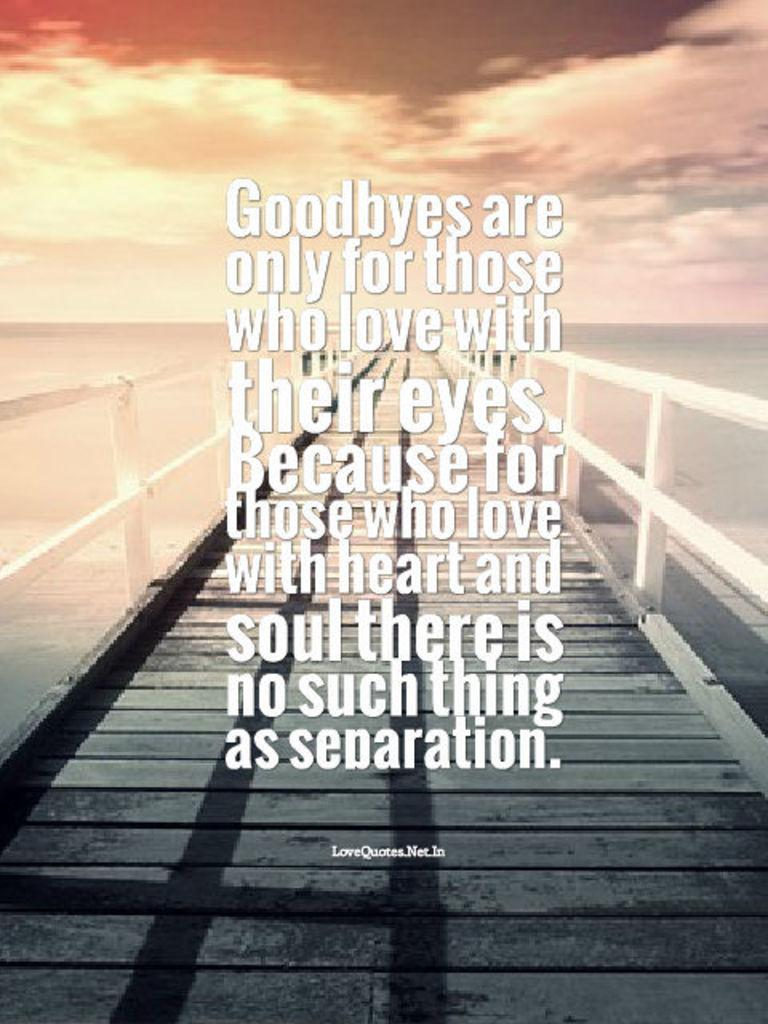<image>
Create a compact narrative representing the image presented. An inspirational sign that says Goodbyes are only for those who love with. 